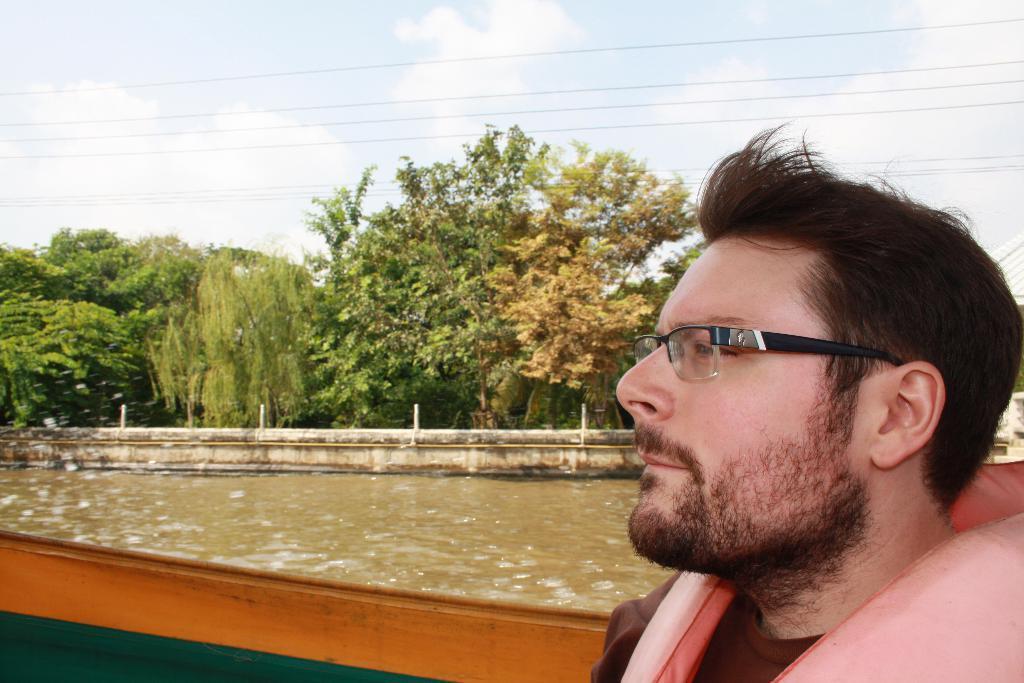Can you describe this image briefly? In front of the image there is a person, beside the person there is water, on the other side of the water, there is a concrete wall, beside the concrete wall there are trees, at the top of the image there are electrical cables passing through and the clouds in the sky. 